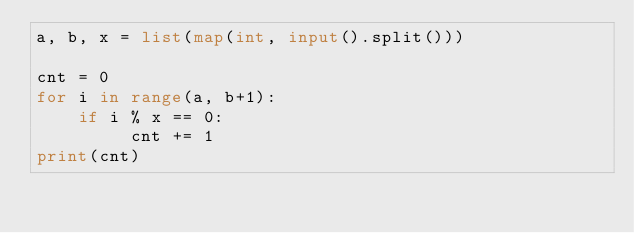<code> <loc_0><loc_0><loc_500><loc_500><_Python_>a, b, x = list(map(int, input().split()))

cnt = 0
for i in range(a, b+1):
    if i % x == 0:
         cnt += 1
print(cnt)</code> 